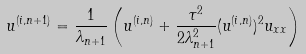<formula> <loc_0><loc_0><loc_500><loc_500>u ^ { ( i , n + 1 ) } = \frac { 1 } { \lambda _ { n + 1 } } \left ( u ^ { ( i , n ) } + \frac { \tau ^ { 2 } } { 2 \lambda ^ { 2 } _ { n + 1 } } ( u ^ { ( i , n ) } ) ^ { 2 } u _ { x x } \right )</formula> 